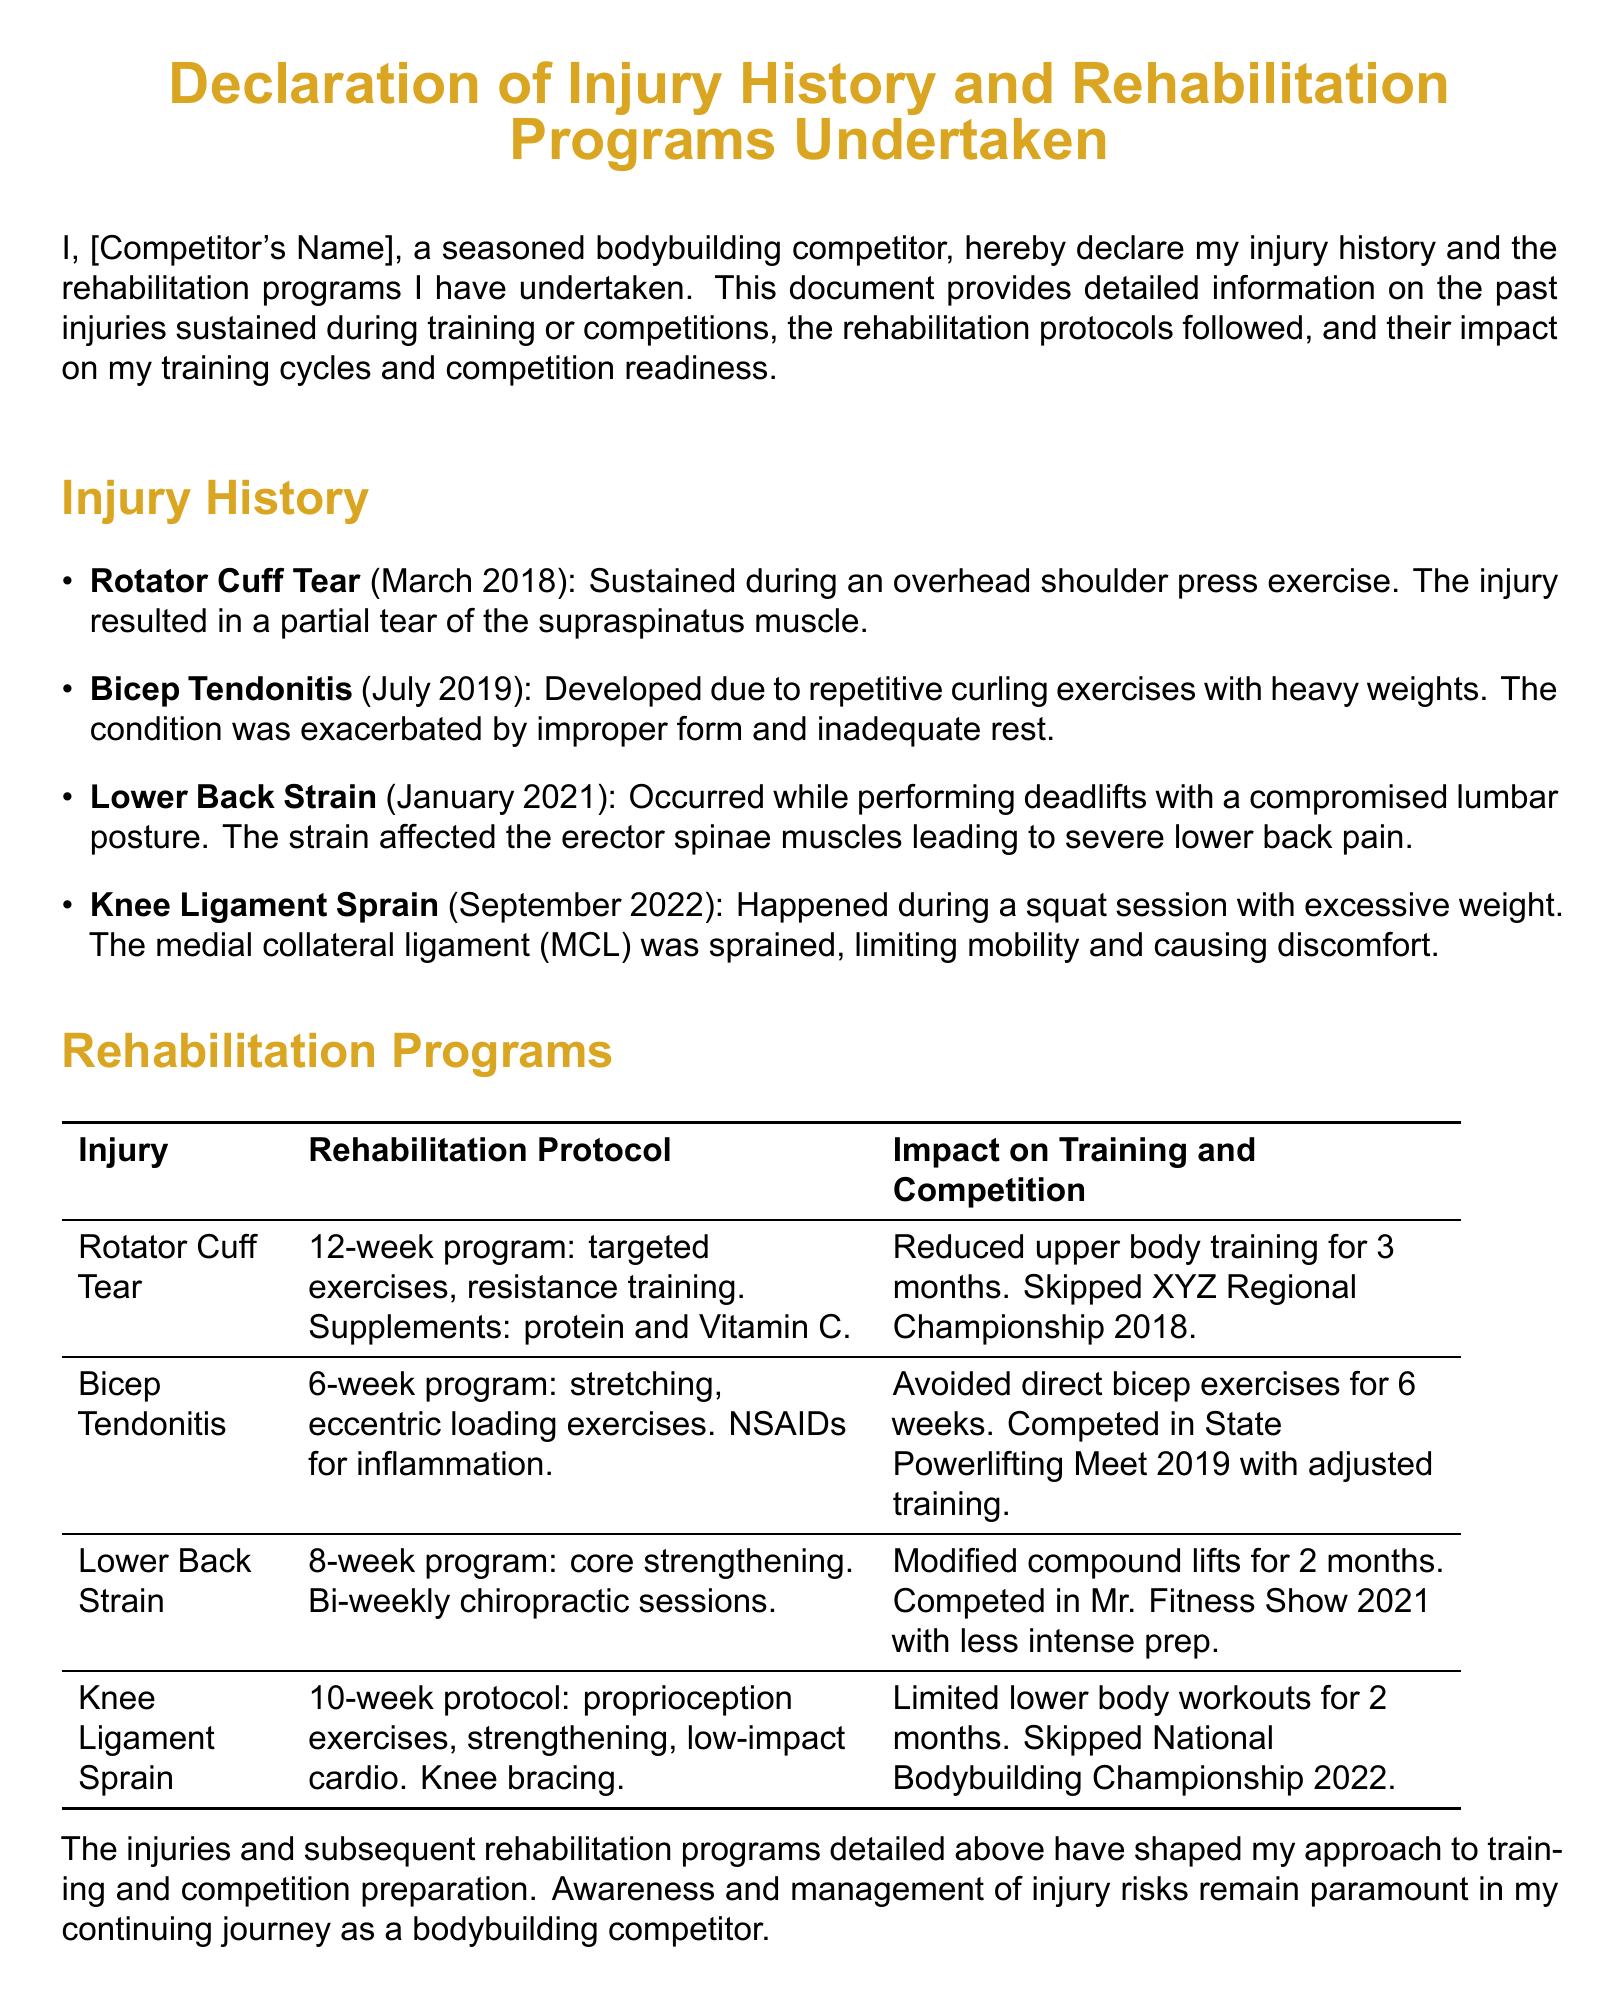What is the name of the competitor? The document states the competitor's name as "[Competitor's Name]," a placeholder indicating the actual name should be inserted.
Answer: [Competitor's Name] When did the Rotator Cuff tear occur? The document highlights the injury history with dates, with the Rotator Cuff tear occurring in March 2018.
Answer: March 2018 What rehabilitation program was followed for Bicep Tendonitis? The rehabilitation program details for Bicep Tendonitis include stretching and eccentric loading exercises for 6 weeks.
Answer: Stretching, eccentric loading exercises How long did the rehabilitation for Lower Back Strain last? The rehabilitation program duration for Lower Back Strain is specified as an 8-week program.
Answer: 8 weeks What was the impact of the Knee Ligament Sprain on competition? The document notes that the Knee Ligament Sprain led to the competitor skipping the National Bodybuilding Championship 2022.
Answer: Skipped National Bodybuilding Championship 2022 Which supplementation was included in the Rotator Cuff rehabilitation? Under the Rotator Cuff rehabilitation protocol, the supplementation listed includes protein and Vitamin C.
Answer: Protein and Vitamin C What was avoided during the rehabilitation of Bicep Tendonitis? During the rehabilitation, the competitor avoided direct bicep exercises for 6 weeks.
Answer: Direct bicep exercises Which injury occurred due to a squat session? The injury that occurred during a squat session is identified as a Knee Ligament Sprain.
Answer: Knee Ligament Sprain What was the focus of the core strengthening program for Lower Back Strain? The core strengthening program aimed at strengthening the erector spinae muscles affected by the strain.
Answer: Erector spinae muscles 